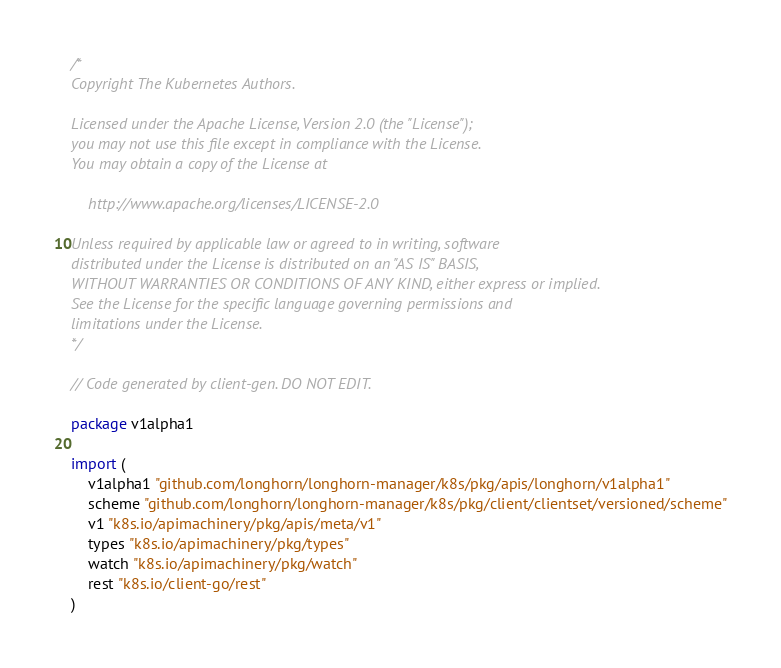Convert code to text. <code><loc_0><loc_0><loc_500><loc_500><_Go_>/*
Copyright The Kubernetes Authors.

Licensed under the Apache License, Version 2.0 (the "License");
you may not use this file except in compliance with the License.
You may obtain a copy of the License at

    http://www.apache.org/licenses/LICENSE-2.0

Unless required by applicable law or agreed to in writing, software
distributed under the License is distributed on an "AS IS" BASIS,
WITHOUT WARRANTIES OR CONDITIONS OF ANY KIND, either express or implied.
See the License for the specific language governing permissions and
limitations under the License.
*/

// Code generated by client-gen. DO NOT EDIT.

package v1alpha1

import (
	v1alpha1 "github.com/longhorn/longhorn-manager/k8s/pkg/apis/longhorn/v1alpha1"
	scheme "github.com/longhorn/longhorn-manager/k8s/pkg/client/clientset/versioned/scheme"
	v1 "k8s.io/apimachinery/pkg/apis/meta/v1"
	types "k8s.io/apimachinery/pkg/types"
	watch "k8s.io/apimachinery/pkg/watch"
	rest "k8s.io/client-go/rest"
)
</code> 